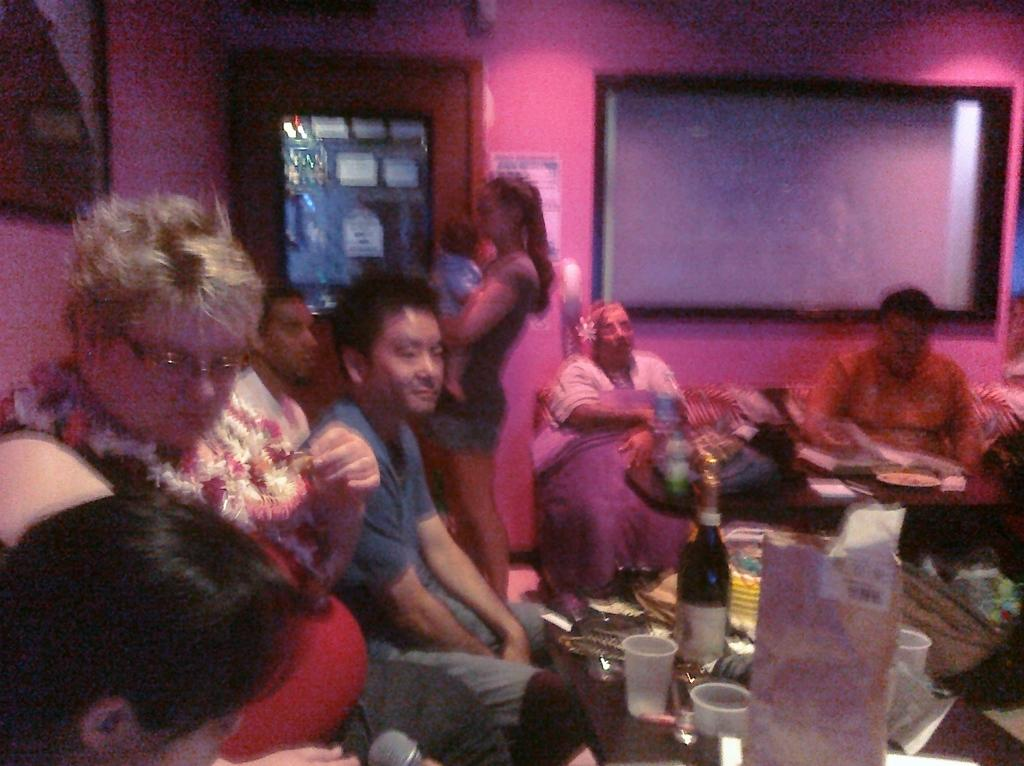How many people are in the image? There is a group of people in the image. What are the people in the image doing? Some people are seated, while a woman is standing. What can be seen on the table in the image? There are glasses, a bottle, and other things on the table. What type of pet can be seen playing with a quarter in the dirt in the image? There is no pet, quarter, or dirt present in the image. 